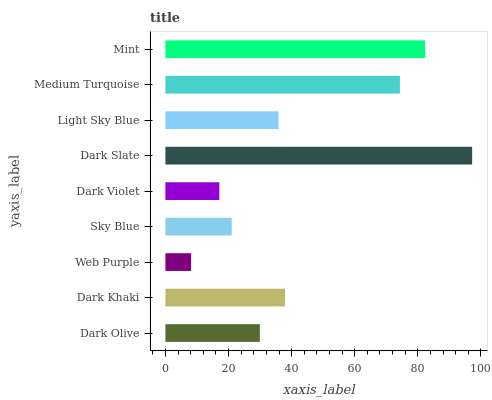Is Web Purple the minimum?
Answer yes or no. Yes. Is Dark Slate the maximum?
Answer yes or no. Yes. Is Dark Khaki the minimum?
Answer yes or no. No. Is Dark Khaki the maximum?
Answer yes or no. No. Is Dark Khaki greater than Dark Olive?
Answer yes or no. Yes. Is Dark Olive less than Dark Khaki?
Answer yes or no. Yes. Is Dark Olive greater than Dark Khaki?
Answer yes or no. No. Is Dark Khaki less than Dark Olive?
Answer yes or no. No. Is Light Sky Blue the high median?
Answer yes or no. Yes. Is Light Sky Blue the low median?
Answer yes or no. Yes. Is Web Purple the high median?
Answer yes or no. No. Is Dark Slate the low median?
Answer yes or no. No. 